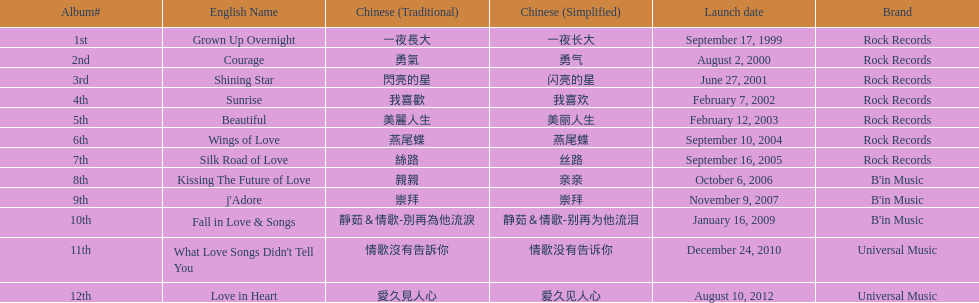What label was she working with before universal music? B'in Music. 